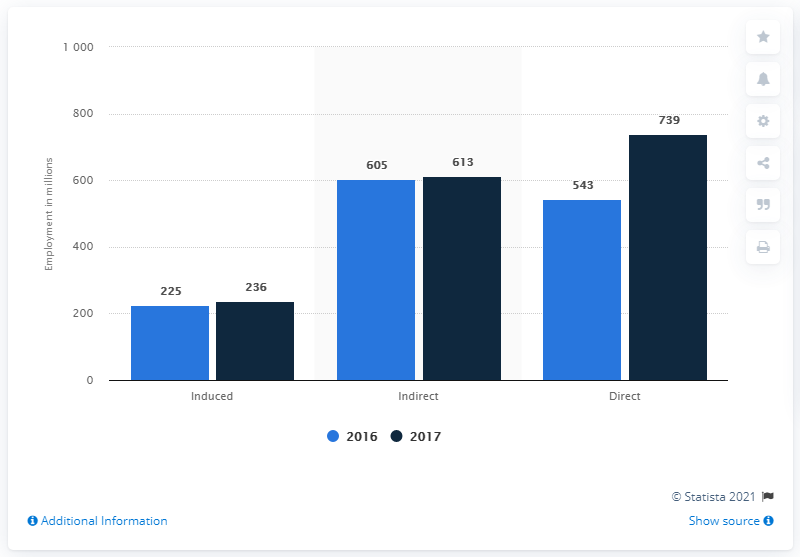Specify some key components in this picture. In the bar graph, the year represented by the blue color is 2016. In 2017, the travel and tourism industry directly contributed a total of 739 jobs to the Canadian economy. The sum of the blue bar is 1373. 